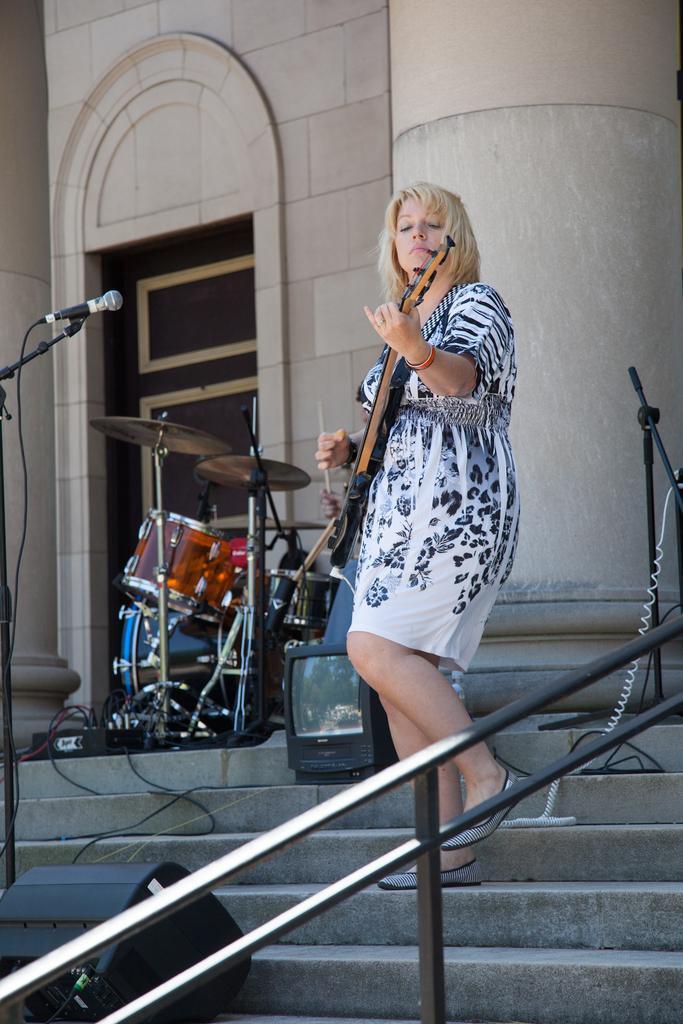Please provide a concise description of this image. In this picture a lady playing a guitar on the steps with all the musical instruments behind her. There is also a mic to the left side of the image. In the background there is a building with huge pillars and a beautiful door. 